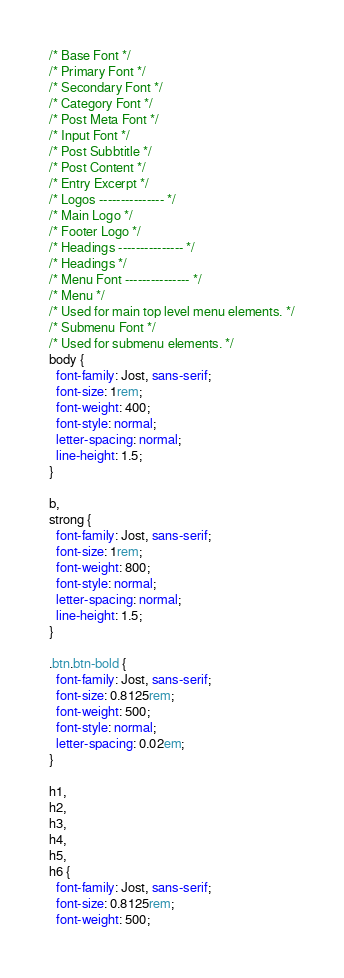Convert code to text. <code><loc_0><loc_0><loc_500><loc_500><_CSS_>/* Base Font */
/* Primary Font */
/* Secondary Font */
/* Category Font */
/* Post Meta Font */
/* Input Font */
/* Post Subbtitle */
/* Post Content */
/* Entry Excerpt */
/* Logos --------------- */
/* Main Logo */
/* Footer Logo */
/* Headings --------------- */
/* Headings */
/* Menu Font --------------- */
/* Menu */
/* Used for main top level menu elements. */
/* Submenu Font */
/* Used for submenu elements. */
body {
  font-family: Jost, sans-serif;
  font-size: 1rem;
  font-weight: 400;
  font-style: normal;
  letter-spacing: normal;
  line-height: 1.5;
}

b,
strong {
  font-family: Jost, sans-serif;
  font-size: 1rem;
  font-weight: 800;
  font-style: normal;
  letter-spacing: normal;
  line-height: 1.5;
}

.btn.btn-bold {
  font-family: Jost, sans-serif;
  font-size: 0.8125rem;
  font-weight: 500;
  font-style: normal;
  letter-spacing: 0.02em;
}

h1,
h2,
h3,
h4,
h5,
h6 {
  font-family: Jost, sans-serif;
  font-size: 0.8125rem;
  font-weight: 500;</code> 